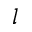<formula> <loc_0><loc_0><loc_500><loc_500>l</formula> 